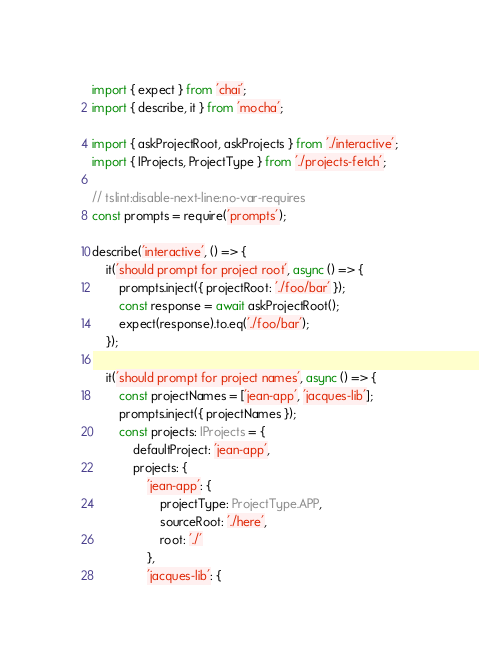<code> <loc_0><loc_0><loc_500><loc_500><_TypeScript_>import { expect } from 'chai';
import { describe, it } from 'mocha';

import { askProjectRoot, askProjects } from './interactive';
import { IProjects, ProjectType } from './projects-fetch';

// tslint:disable-next-line:no-var-requires
const prompts = require('prompts');

describe('interactive', () => {
    it('should prompt for project root', async () => {
        prompts.inject({ projectRoot: './foo/bar' });
        const response = await askProjectRoot();
        expect(response).to.eq('./foo/bar');
    });

    it('should prompt for project names', async () => {
        const projectNames = ['jean-app', 'jacques-lib'];
        prompts.inject({ projectNames });
        const projects: IProjects = {
            defaultProject: 'jean-app',
            projects: {
                'jean-app': {
                    projectType: ProjectType.APP,
                    sourceRoot: './here',
                    root: './'
                },
                'jacques-lib': {</code> 